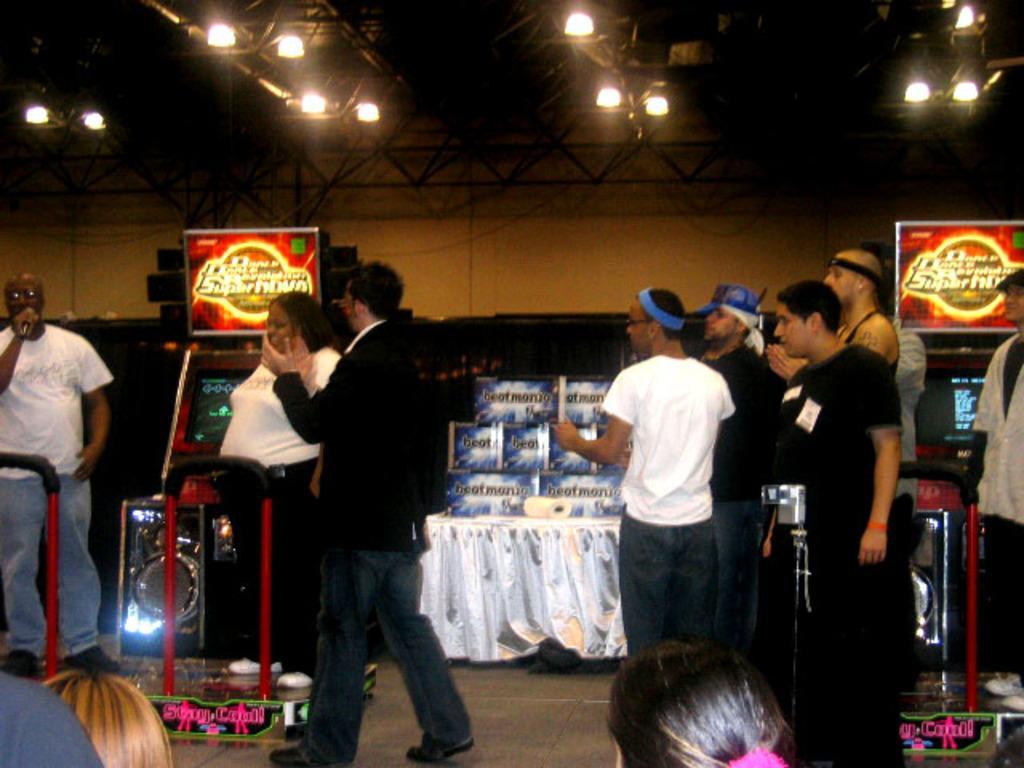How would you summarize this image in a sentence or two? There are group of people standing. This is a table covered with a white cloth. I can see a tissue paper roll and few objects on it. I can see a speaker. I think these are the video games. These are the lights attached to the lighting truss. Here is a man standing and holding a mike. 